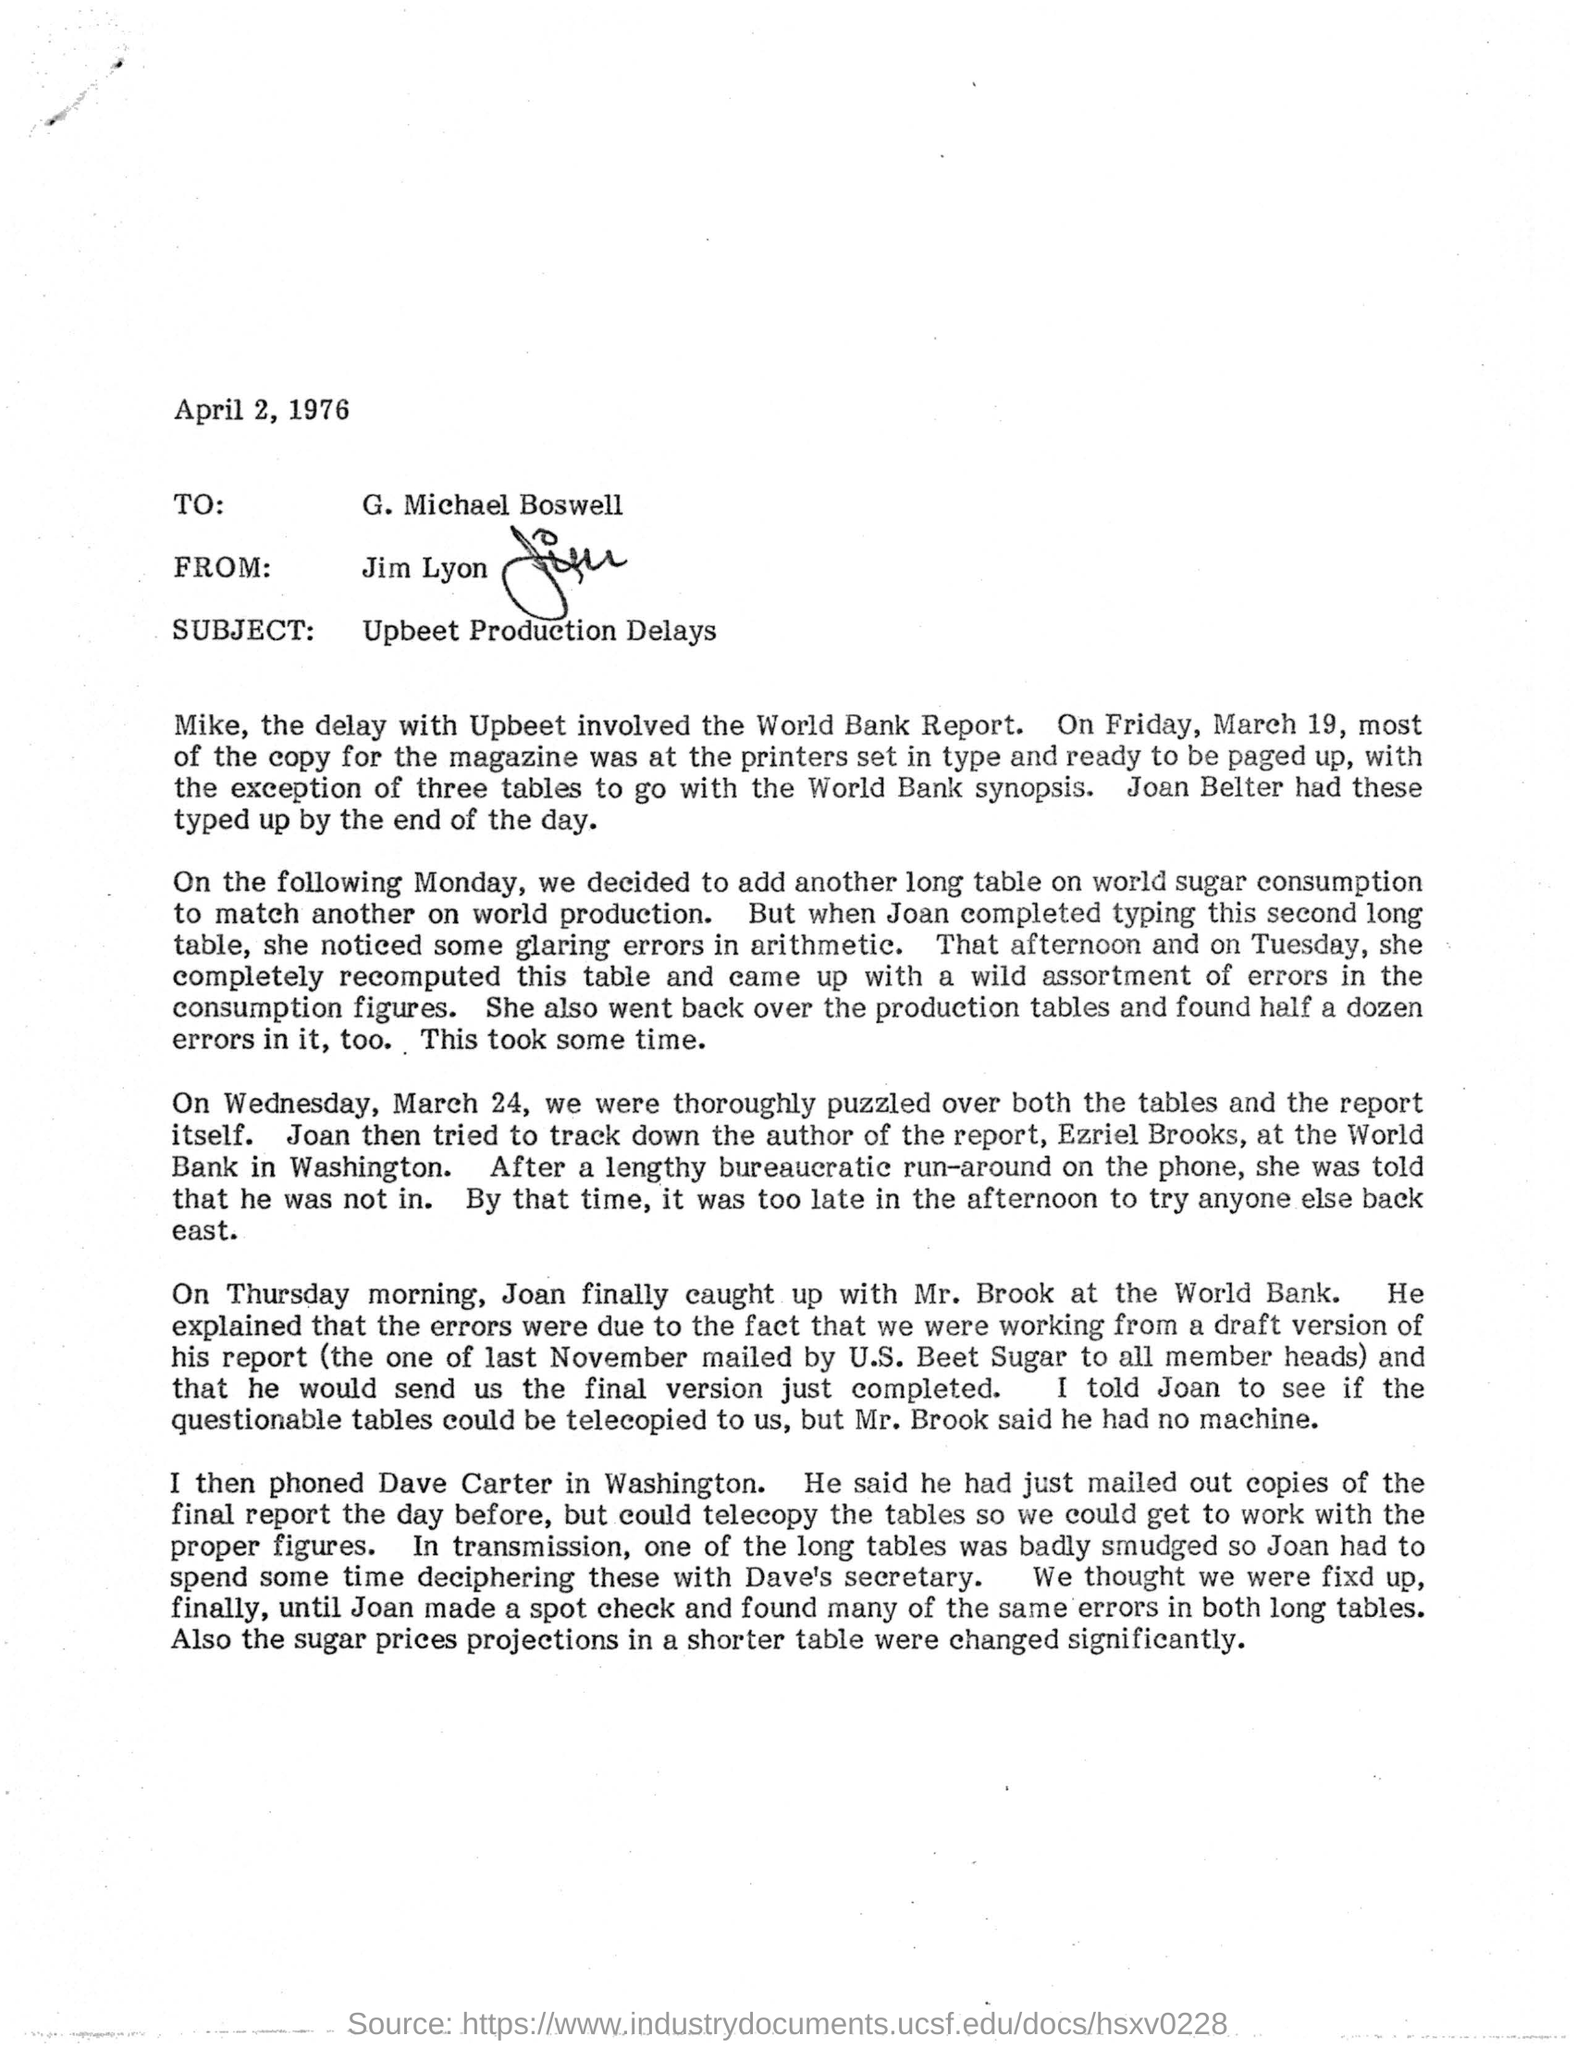Indicate a few pertinent items in this graphic. The subject of the letter is about upbeet production delays. This letter is addressed to G. Michael Boswell. 